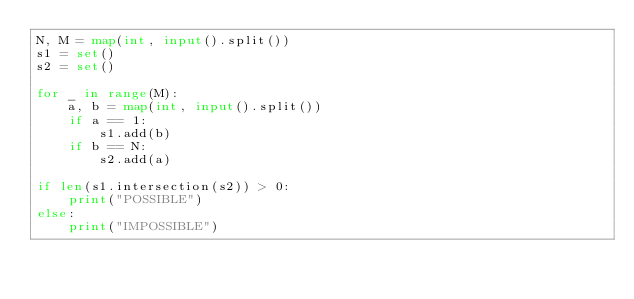<code> <loc_0><loc_0><loc_500><loc_500><_Python_>N, M = map(int, input().split())
s1 = set()
s2 = set()

for _ in range(M):
    a, b = map(int, input().split())
    if a == 1:
        s1.add(b)
    if b == N:
        s2.add(a)

if len(s1.intersection(s2)) > 0:
    print("POSSIBLE")
else:
    print("IMPOSSIBLE")
</code> 